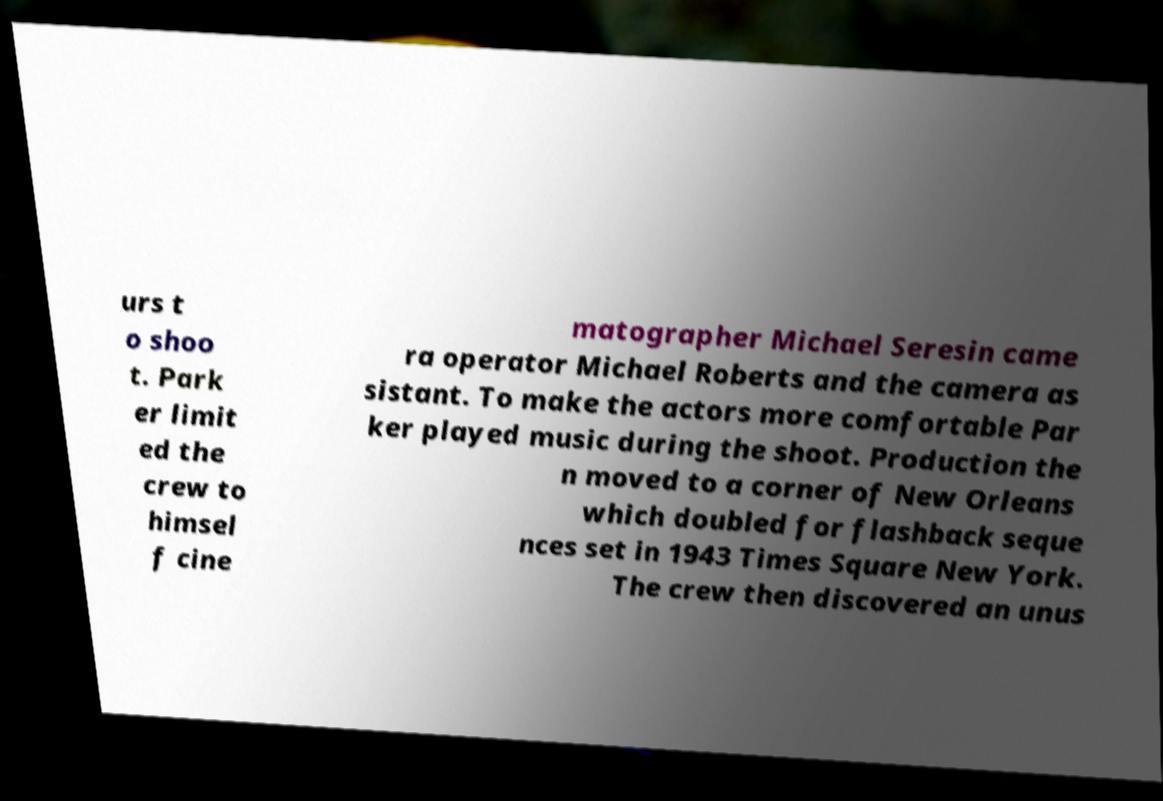Could you assist in decoding the text presented in this image and type it out clearly? urs t o shoo t. Park er limit ed the crew to himsel f cine matographer Michael Seresin came ra operator Michael Roberts and the camera as sistant. To make the actors more comfortable Par ker played music during the shoot. Production the n moved to a corner of New Orleans which doubled for flashback seque nces set in 1943 Times Square New York. The crew then discovered an unus 